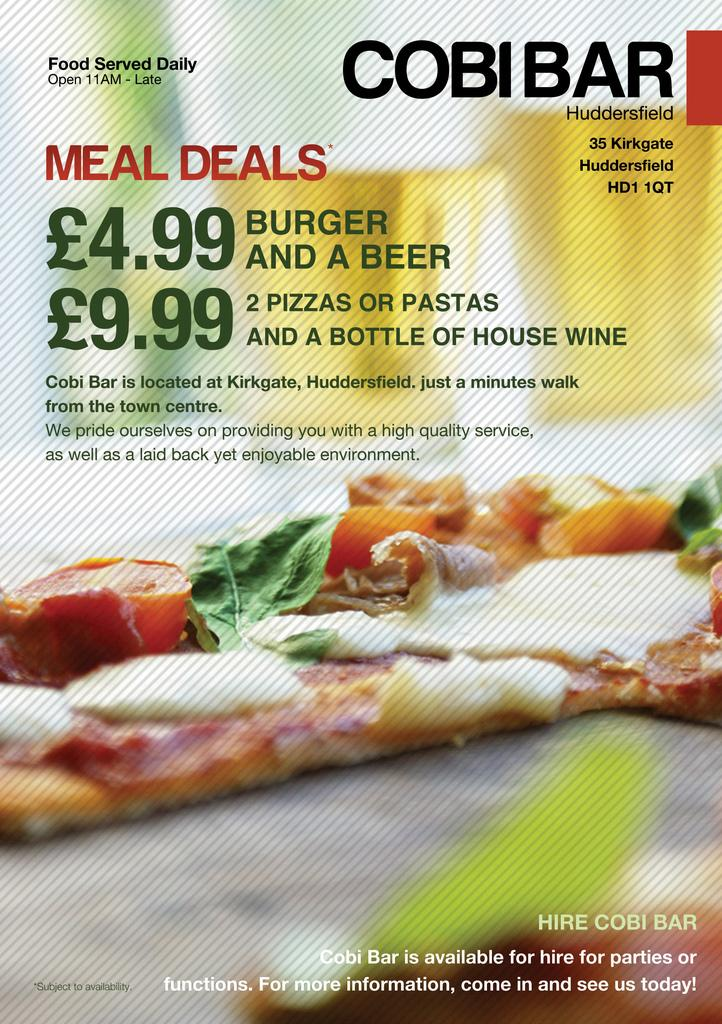What is featured in the image? There is a poster in the image. What is depicted on the poster? The poster contains a picture of food. Is there any text on the poster? Yes, there is text at the top of the poster. What type of vessel is used to transport the dirt in the image? There is no vessel or dirt present in the image; it only features a poster with a picture of food and text. 